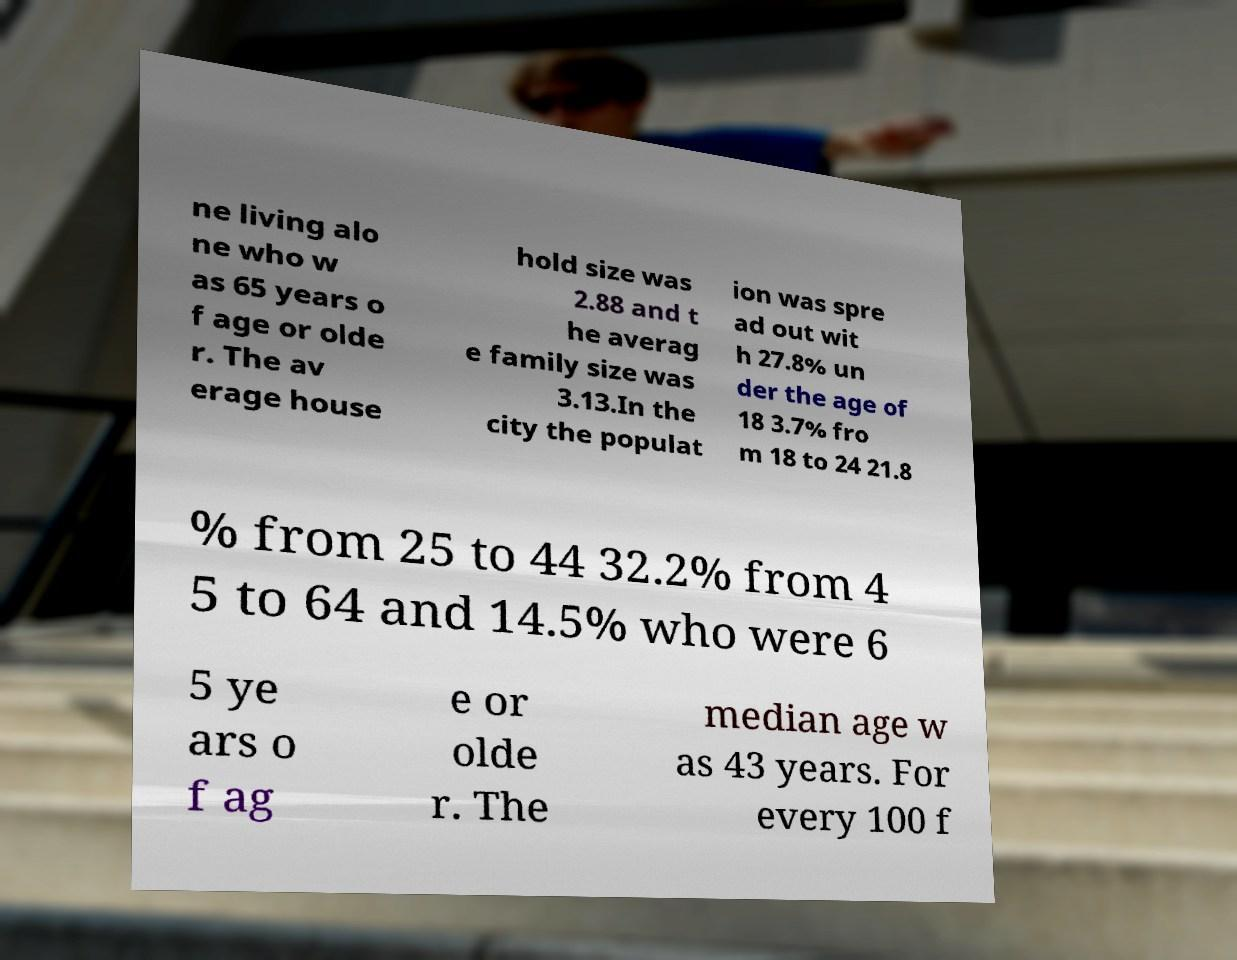Could you extract and type out the text from this image? ne living alo ne who w as 65 years o f age or olde r. The av erage house hold size was 2.88 and t he averag e family size was 3.13.In the city the populat ion was spre ad out wit h 27.8% un der the age of 18 3.7% fro m 18 to 24 21.8 % from 25 to 44 32.2% from 4 5 to 64 and 14.5% who were 6 5 ye ars o f ag e or olde r. The median age w as 43 years. For every 100 f 